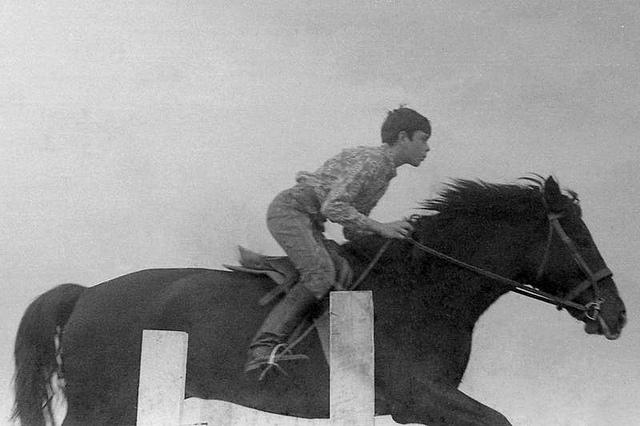Is the person in a competition?
Keep it brief. No. What activity is this?
Short answer required. Horseback riding. What does this person doing?
Give a very brief answer. Riding horse. What color is the photo tinted?
Quick response, please. Black and white. Is this boy doing a trick?
Concise answer only. No. Is the person in the photo attacking the horse?
Give a very brief answer. No. Is the image in black and white?
Short answer required. Yes. Are these people wearing hats?
Concise answer only. No. 